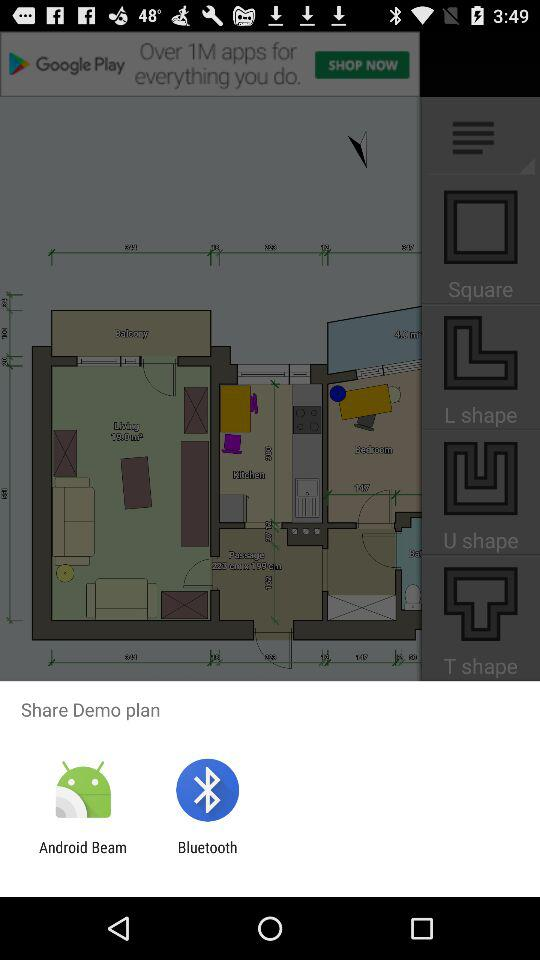Through which application can we share the demo plan? You can share it through "Android Beam" and "Bluetooth". 